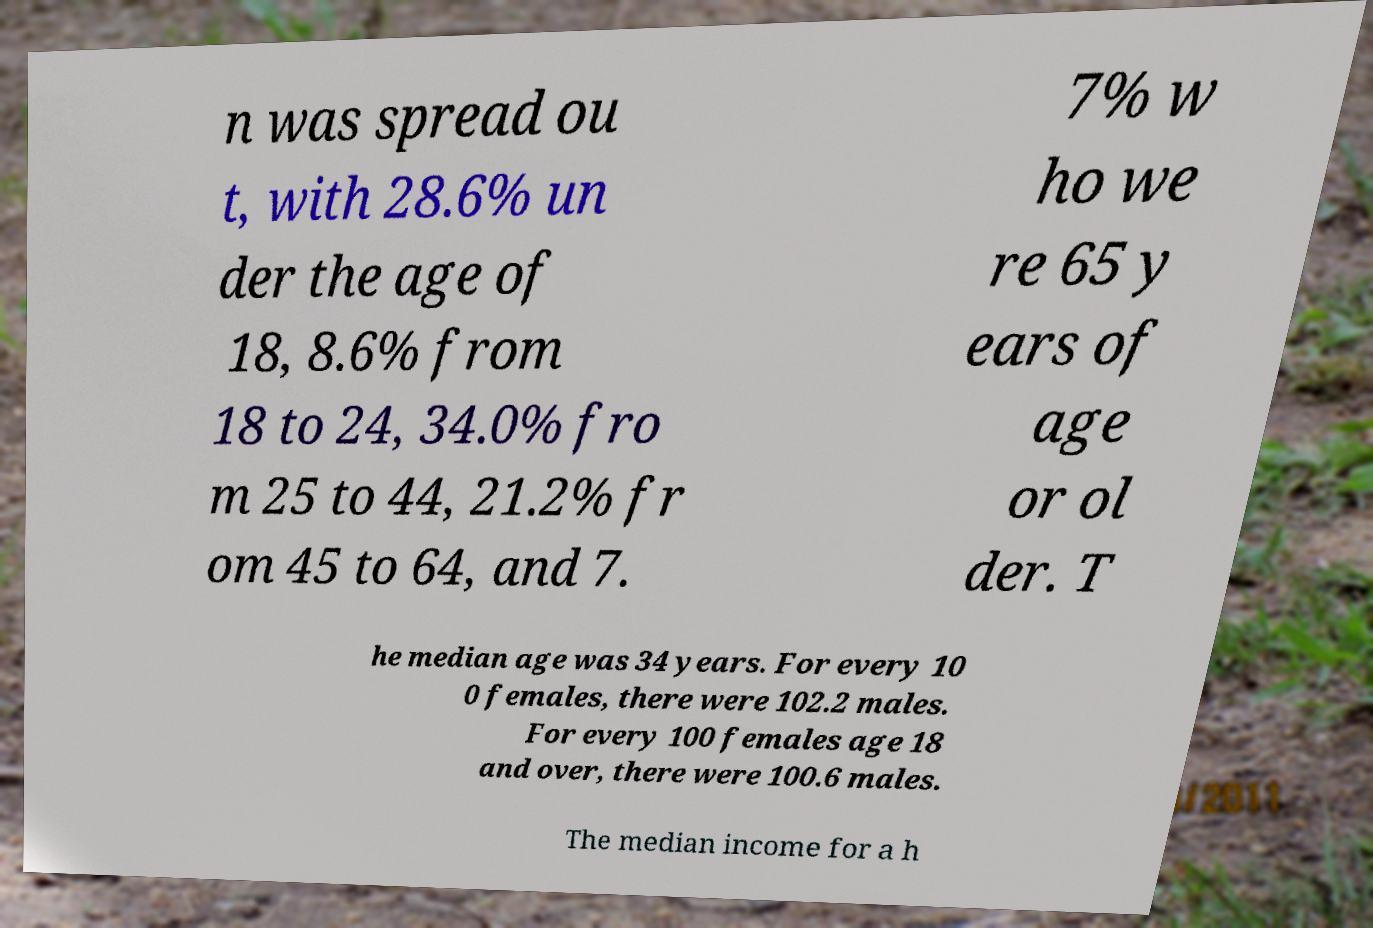Please read and relay the text visible in this image. What does it say? n was spread ou t, with 28.6% un der the age of 18, 8.6% from 18 to 24, 34.0% fro m 25 to 44, 21.2% fr om 45 to 64, and 7. 7% w ho we re 65 y ears of age or ol der. T he median age was 34 years. For every 10 0 females, there were 102.2 males. For every 100 females age 18 and over, there were 100.6 males. The median income for a h 